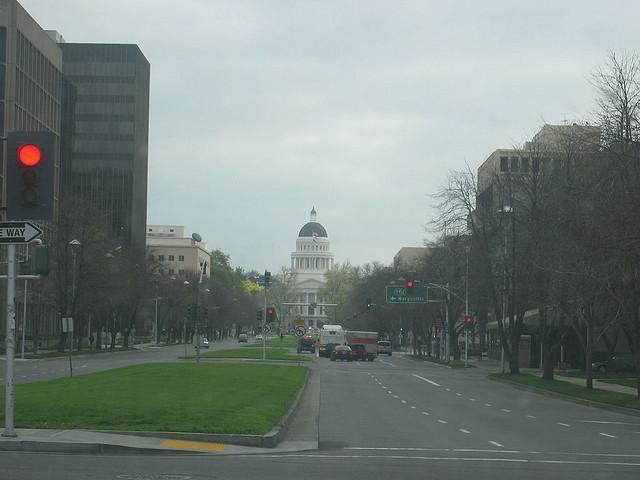How many traffic lights are red?
Give a very brief answer. 4. How many keyboards are there?
Give a very brief answer. 0. 